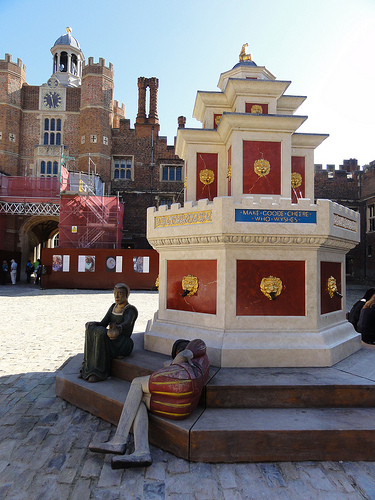<image>
Is there a sky behind the building? Yes. From this viewpoint, the sky is positioned behind the building, with the building partially or fully occluding the sky. 